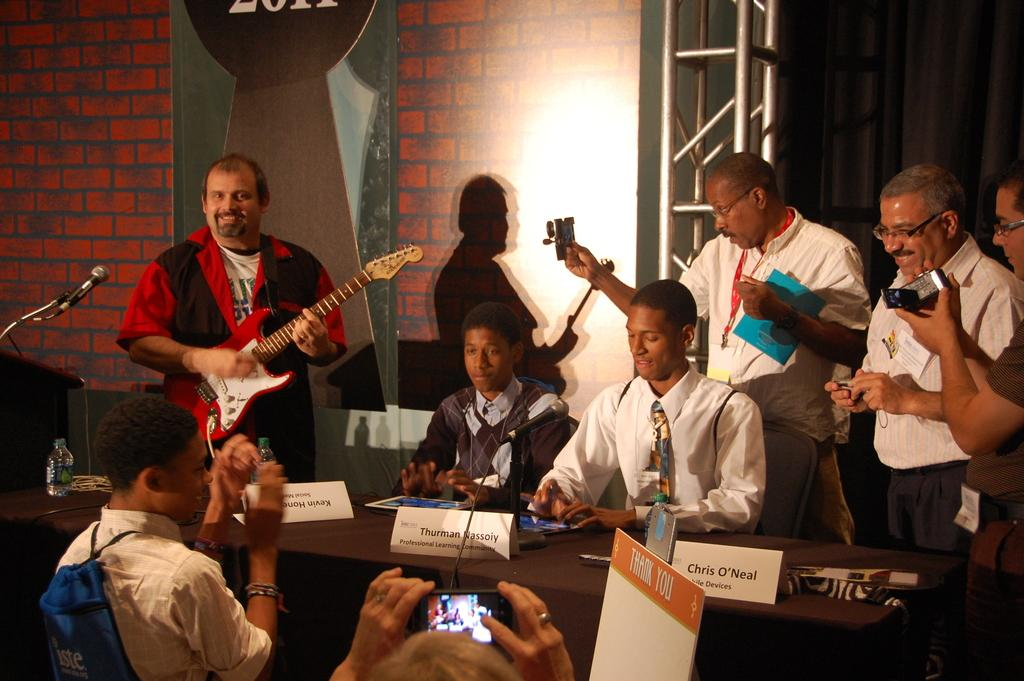What is the man in the image doing? The man is playing a guitar in the image. What are the other persons in the image doing? The other persons are sitting on chairs in the image. What is present in front of the persons sitting on chairs? There is a table in front of the persons. What electronic device is on the table? There is an iPad on the table. What is the man holding in his hand? The man is holding a camera in his hand. Is it raining in the image? There is no indication of rain in the image. What nerve is responsible for the man's ability to play the guitar? The image does not provide information about the man's nerves or his ability to play the guitar. 